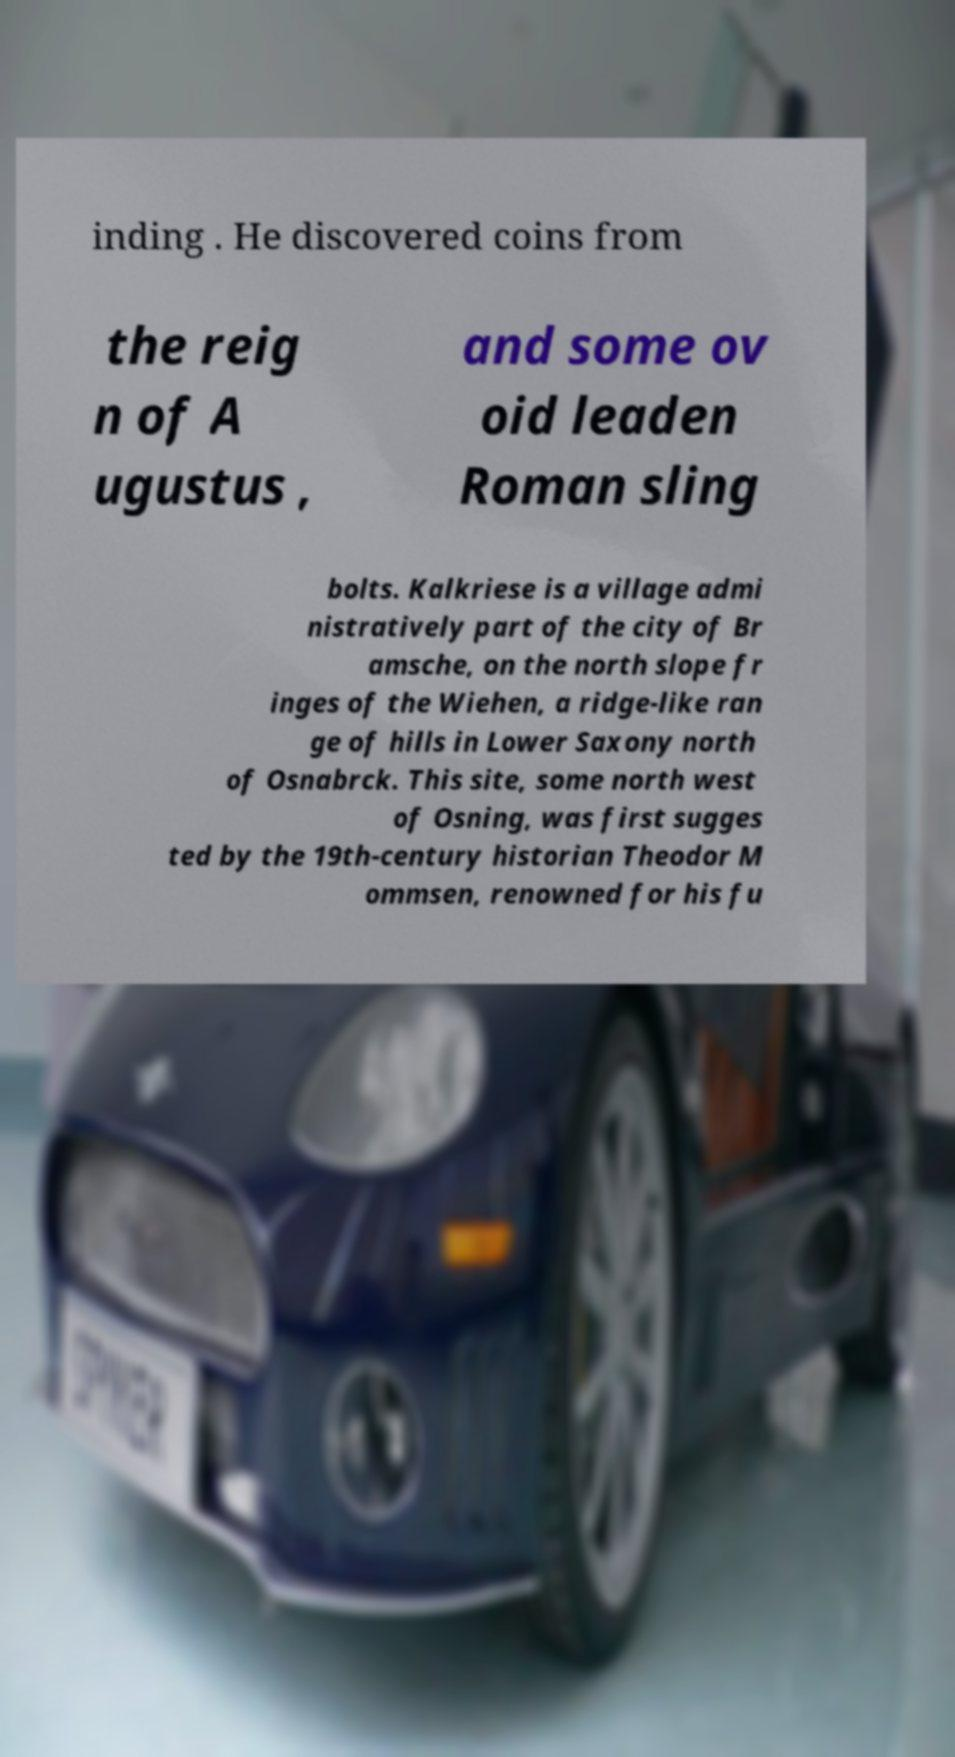For documentation purposes, I need the text within this image transcribed. Could you provide that? inding . He discovered coins from the reig n of A ugustus , and some ov oid leaden Roman sling bolts. Kalkriese is a village admi nistratively part of the city of Br amsche, on the north slope fr inges of the Wiehen, a ridge-like ran ge of hills in Lower Saxony north of Osnabrck. This site, some north west of Osning, was first sugges ted by the 19th-century historian Theodor M ommsen, renowned for his fu 